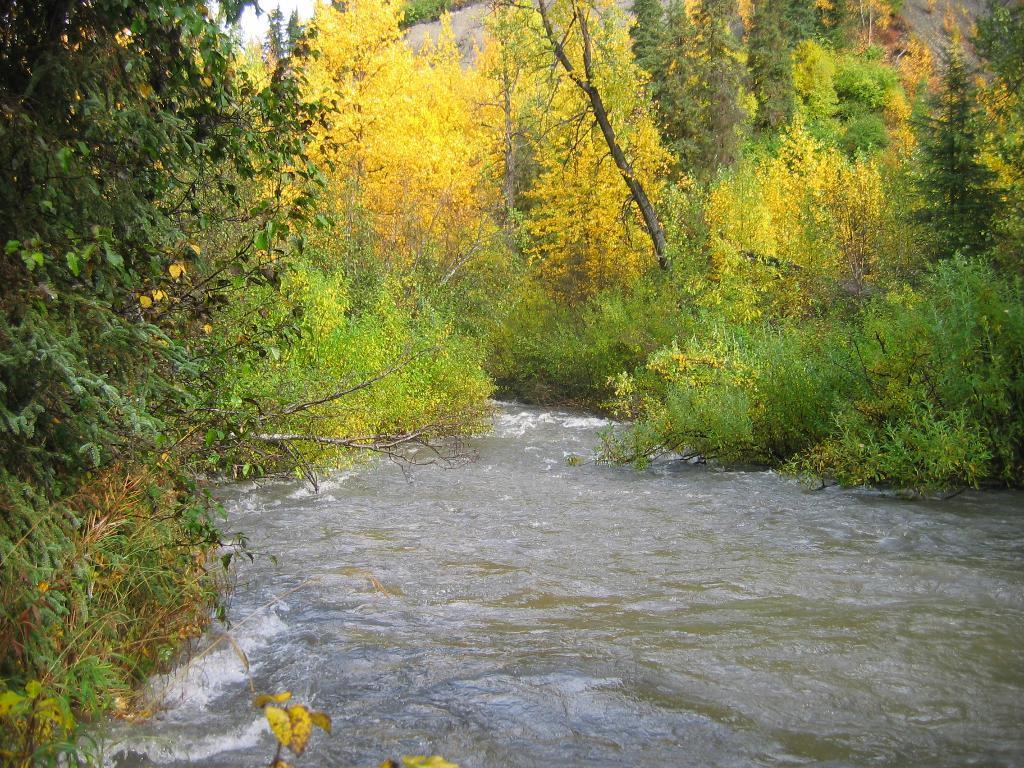How would you summarize this image in a sentence or two? In this image, we can see so many trees, plants and water. Here we can see the sky. 